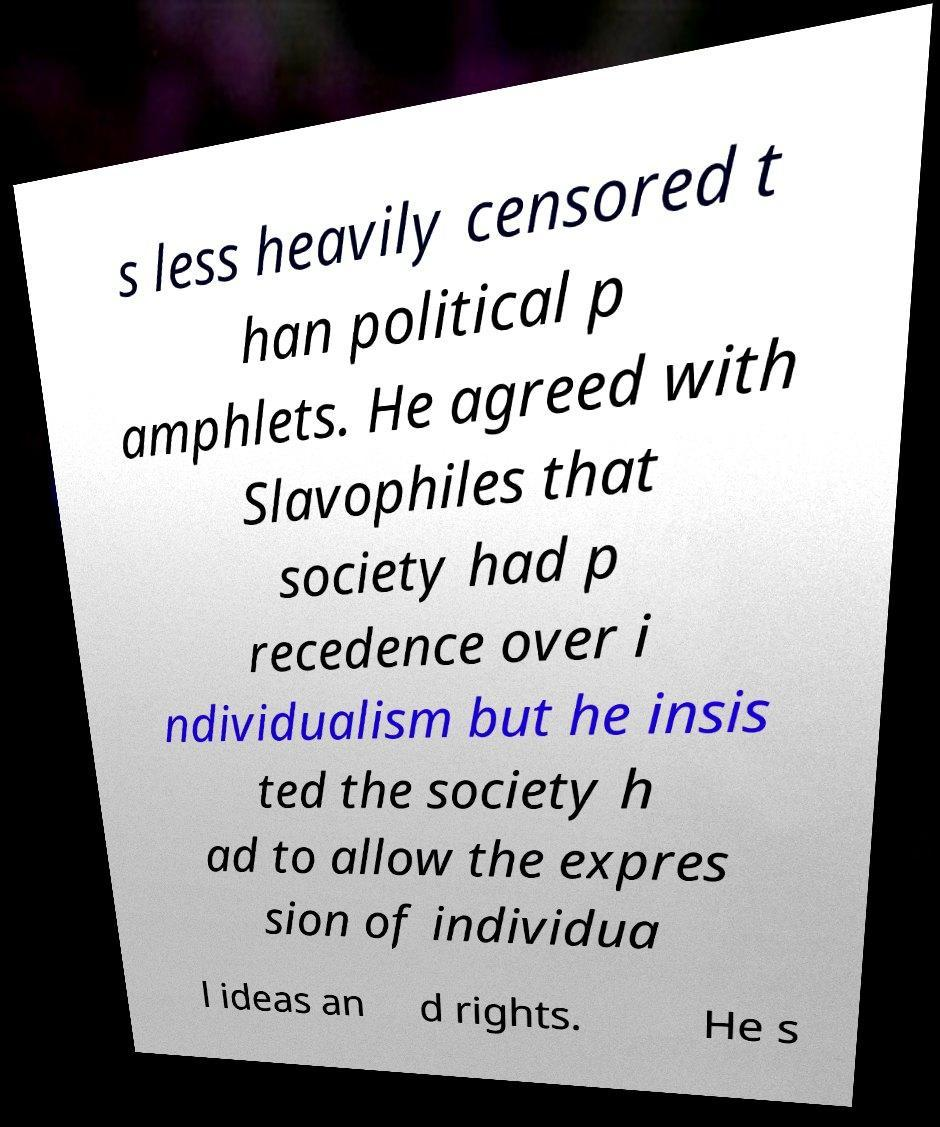I need the written content from this picture converted into text. Can you do that? s less heavily censored t han political p amphlets. He agreed with Slavophiles that society had p recedence over i ndividualism but he insis ted the society h ad to allow the expres sion of individua l ideas an d rights. He s 